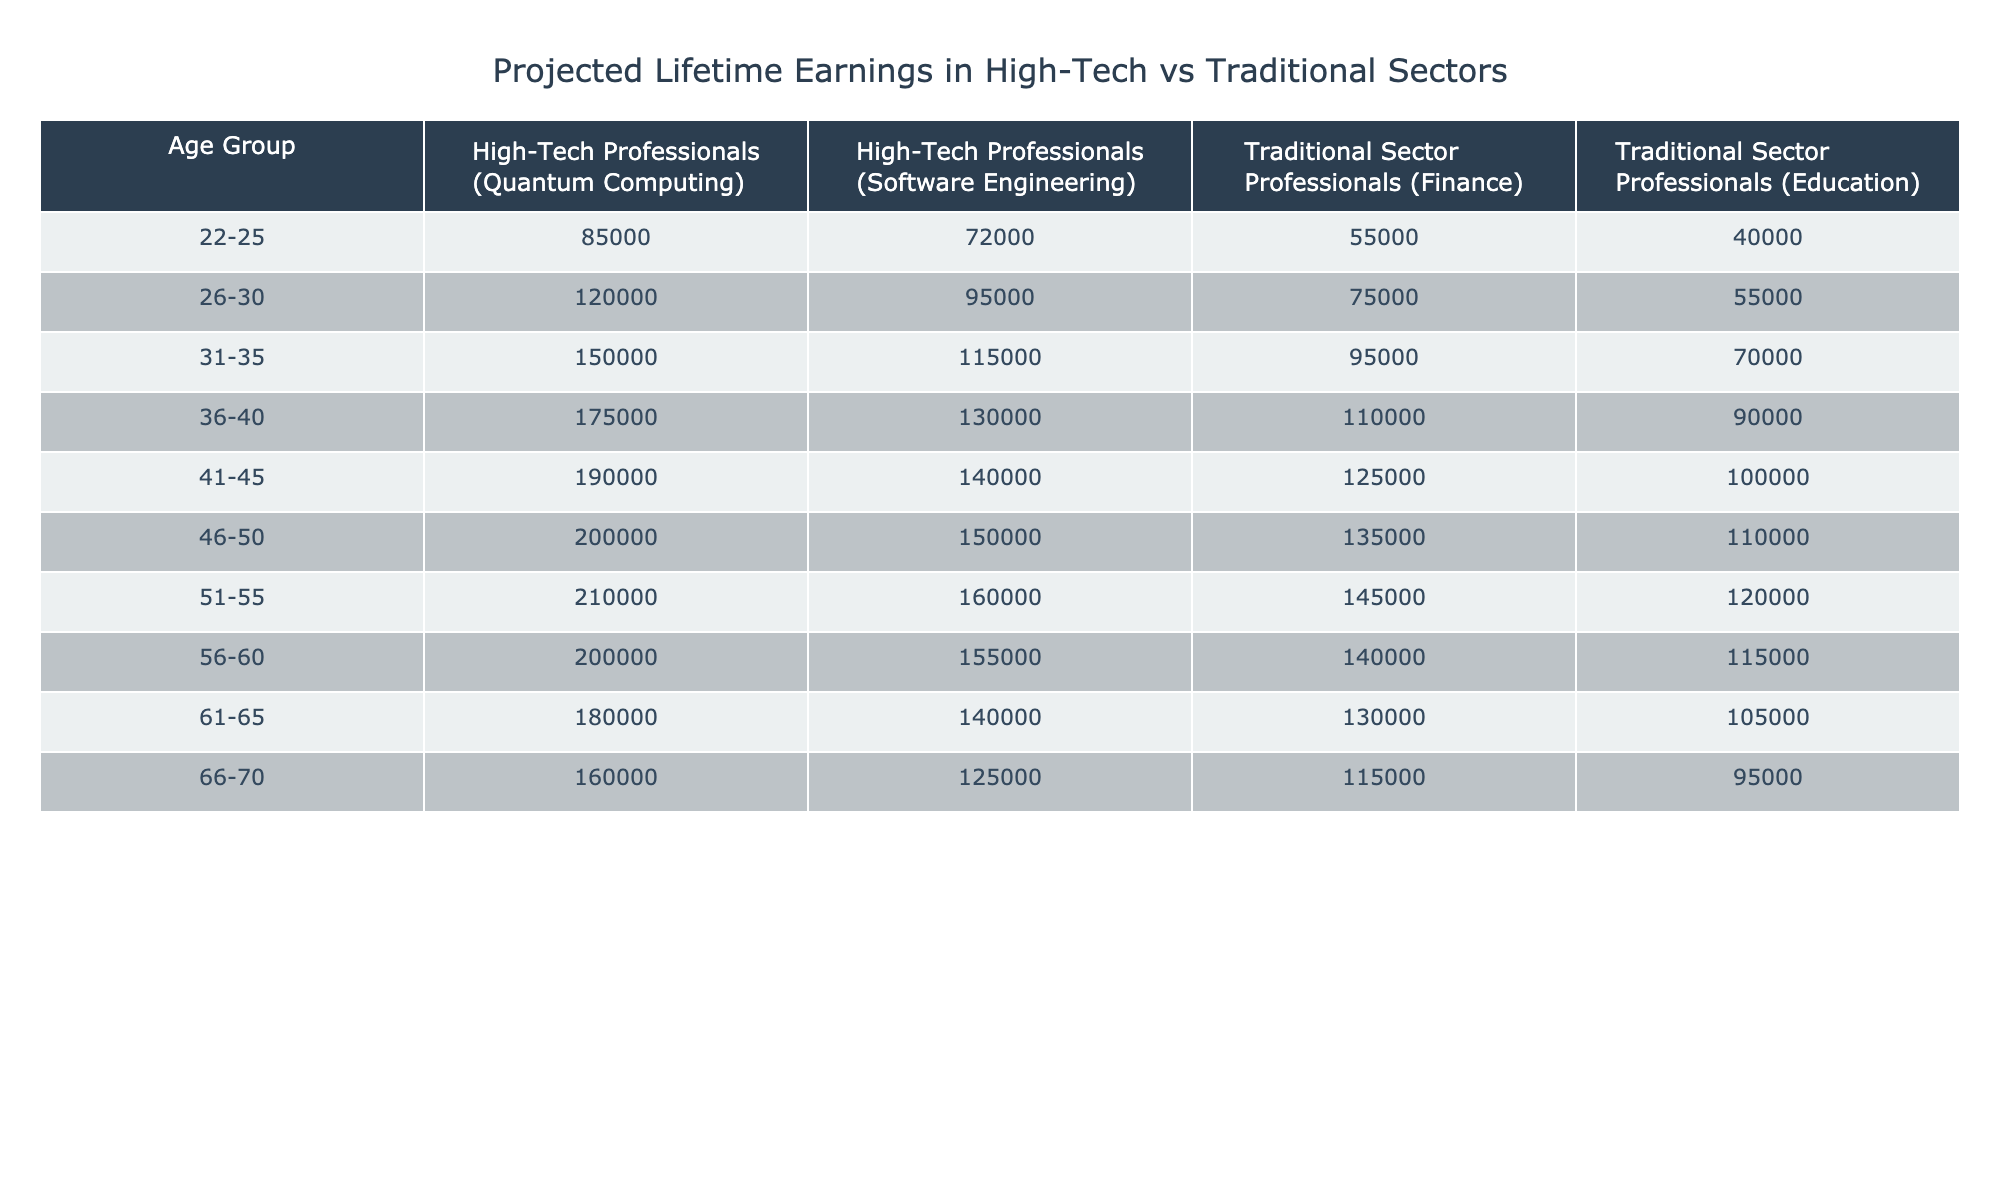What is the projected lifetime earnings for High-Tech Professionals in Quantum Computing at age 36-40? The table states that the earnings for High-Tech Professionals in Quantum Computing in the age group 36-40 is 175,000.
Answer: 175000 What is the difference in projected lifetime earnings between High-Tech Professionals in Software Engineering and Traditional Sector Professionals in Finance at age 41-45? For Software Engineering in the 41-45 age group, the earnings are 140,000. For Finance, it is 125,000. The difference is 140,000 - 125,000 = 15,000.
Answer: 15000 Are the projected earnings for Traditional Sector Professionals in Education at age 26-30 greater than those in the same sector at age 31-35? At age 26-30, the earnings in Education is 55,000, while at age 31-35 it is 70,000. Since 55,000 is less than 70,000, the statement is false.
Answer: No What is the average projected lifetime earnings for High-Tech Professionals in Quantum Computing from ages 51-55? For ages 51-55, the earnings listed are 210,000. Since there is only one data point, the average is simply 210,000.
Answer: 210000 How much more do High-Tech Professionals in Software Engineering earn than Traditional Sector Professionals in Education at age 46-50? In the age group 46-50, earnings for Software Engineering are 150,000, while for Education they are 110,000. The difference is 150,000 - 110,000 = 40,000.
Answer: 40000 At what age group do High-Tech Professionals in Quantum Computing start earning less than those in Software Engineering? In the data, starting at age 56-60, High-Tech Professionals in Quantum Computing earn 200,000, while Software Engineering earns 155,000. This means they do not earn less in any age group until the next group, 61-65, where Quantum drops to 180,000 while Software is 140,000.
Answer: 61-65 What is the total projected lifetime earnings for Traditional Sector Professionals in Finance from ages 22-25 to 66-70? The earnings for Finance across the age groups are 55,000, 75,000, 95,000, 110,000, 125,000, 135,000, 145,000, 140,000, 130,000, and 115,000. Summing these values gives 55,000 + 75,000 + 95,000 + 110,000 + 125,000 + 135,000 + 145,000 + 140,000 + 130,000 + 115,000 = 1,050,000.
Answer: 1050000 